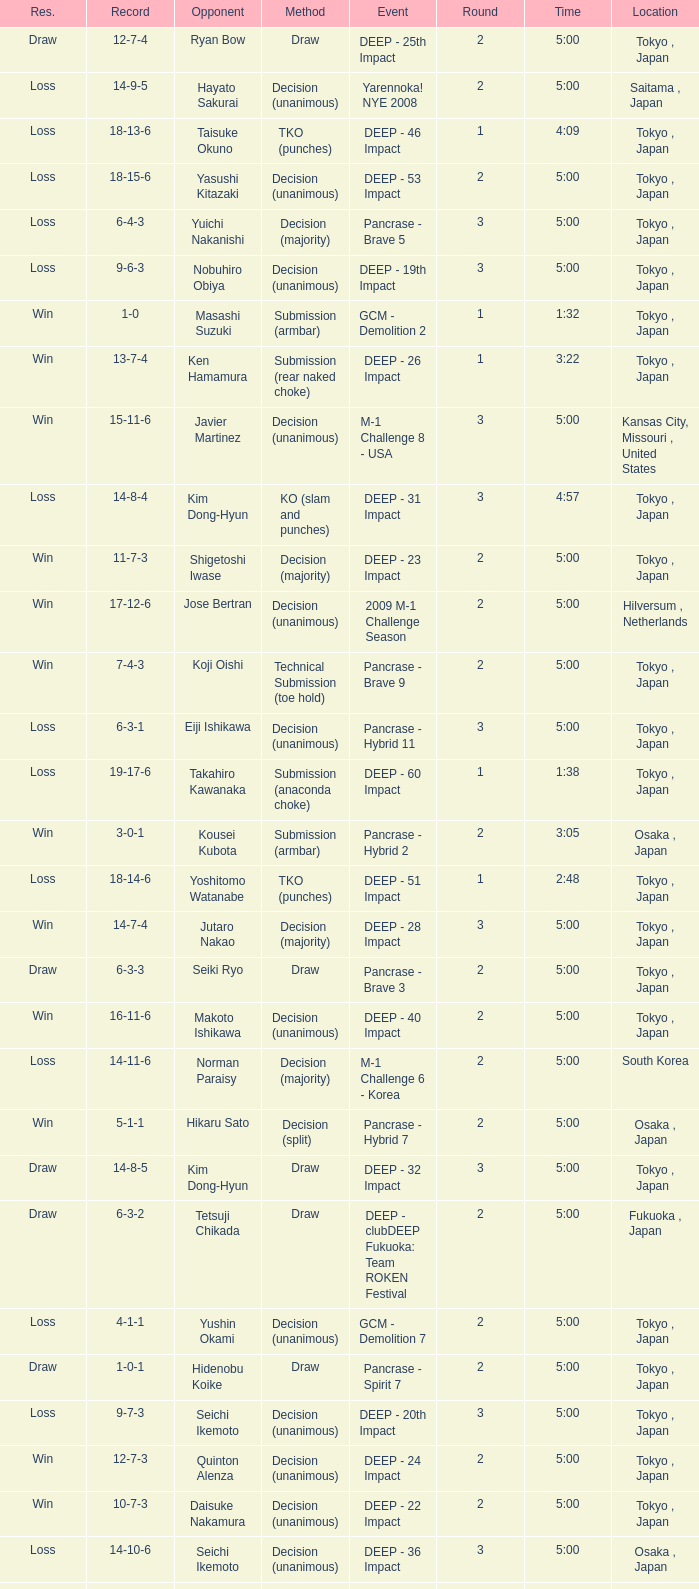What is the location when the record is 5-1-1? Osaka , Japan. 